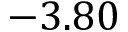Convert formula to latex. <formula><loc_0><loc_0><loc_500><loc_500>- 3 . 8 0</formula> 